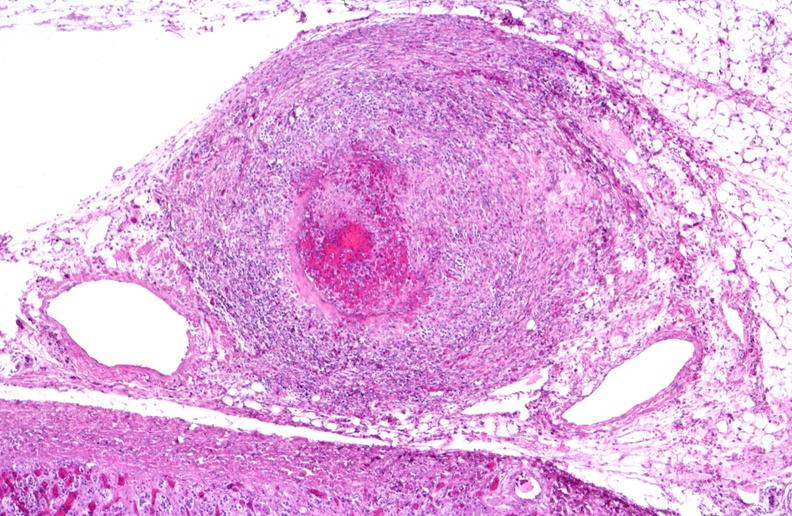s stillborn macerated present?
Answer the question using a single word or phrase. No 